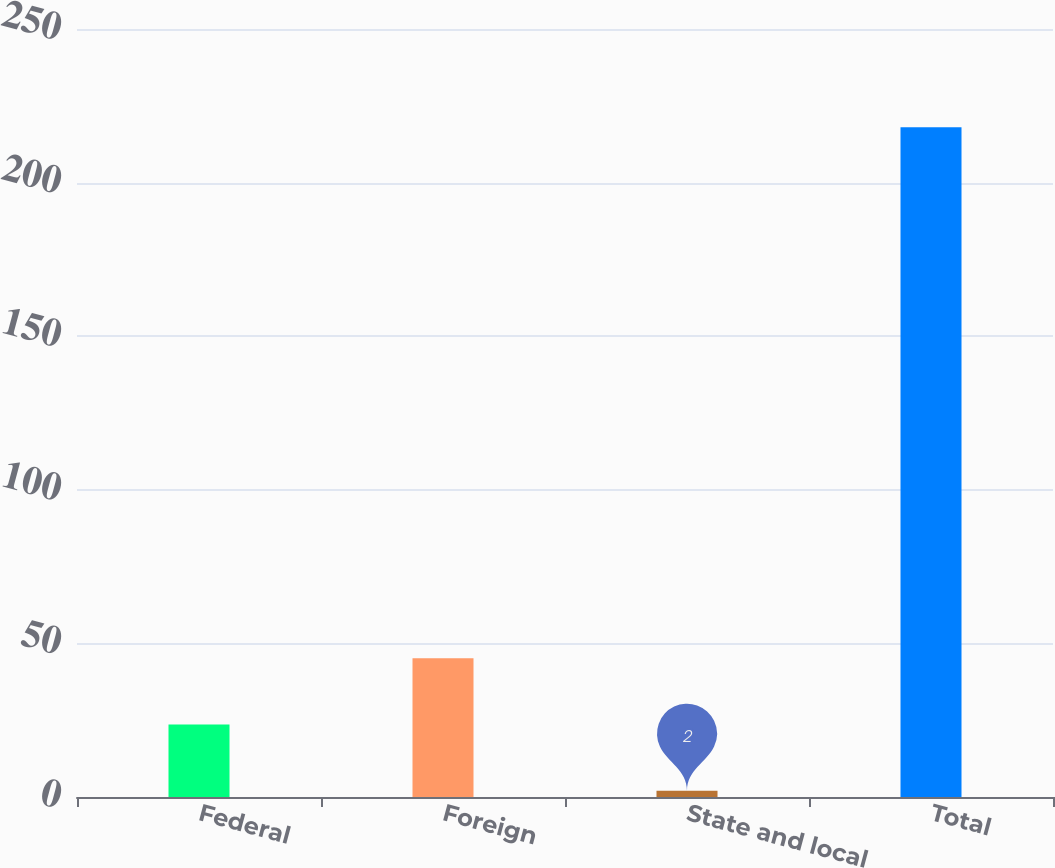<chart> <loc_0><loc_0><loc_500><loc_500><bar_chart><fcel>Federal<fcel>Foreign<fcel>State and local<fcel>Total<nl><fcel>23.6<fcel>45.2<fcel>2<fcel>218<nl></chart> 